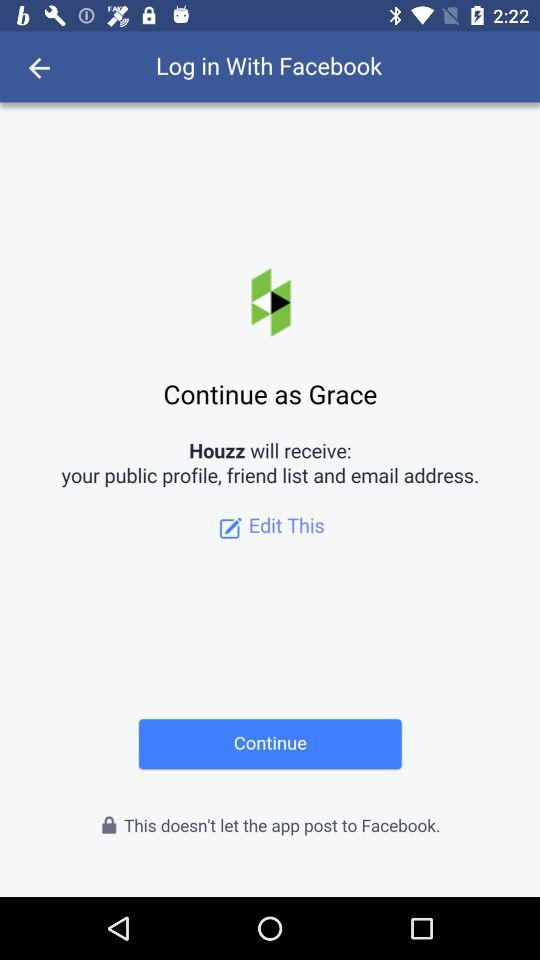What application is asking for permission? The application asking for permission is "Houzz". 